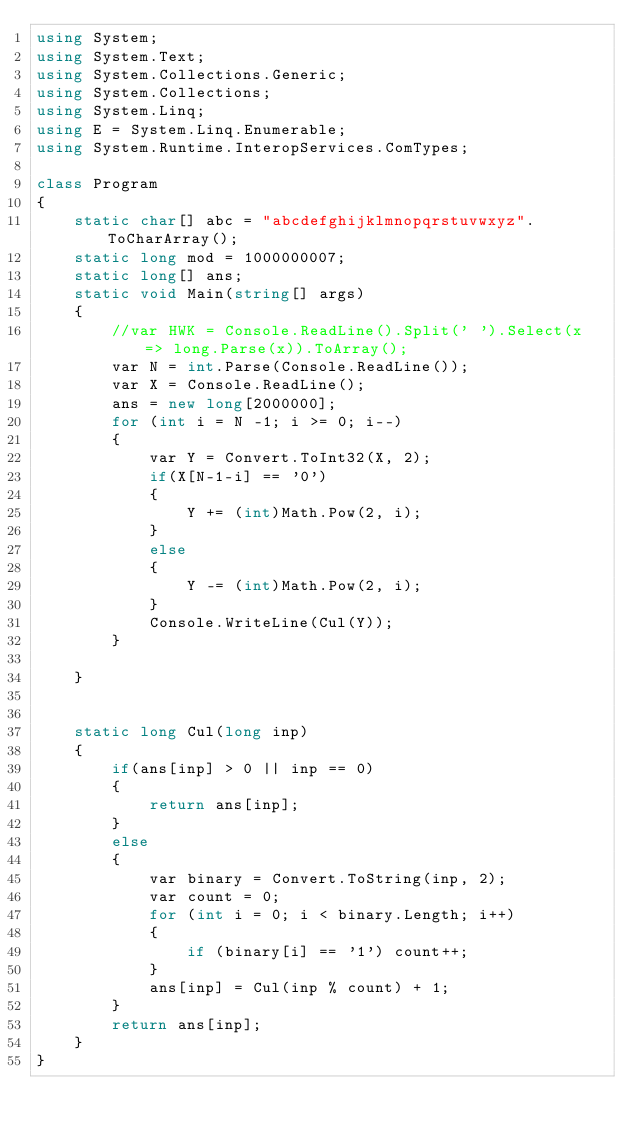Convert code to text. <code><loc_0><loc_0><loc_500><loc_500><_C#_>using System;
using System.Text;
using System.Collections.Generic;
using System.Collections;
using System.Linq;
using E = System.Linq.Enumerable;
using System.Runtime.InteropServices.ComTypes;

class Program
{
    static char[] abc = "abcdefghijklmnopqrstuvwxyz".ToCharArray();
    static long mod = 1000000007;
    static long[] ans;
    static void Main(string[] args)
    {
        //var HWK = Console.ReadLine().Split(' ').Select(x => long.Parse(x)).ToArray();
        var N = int.Parse(Console.ReadLine());
        var X = Console.ReadLine();
        ans = new long[2000000];
        for (int i = N -1; i >= 0; i--)
        {
            var Y = Convert.ToInt32(X, 2);
            if(X[N-1-i] == '0')
            {
                Y += (int)Math.Pow(2, i);
            }
            else
            {
                Y -= (int)Math.Pow(2, i);
            }
            Console.WriteLine(Cul(Y));
        }
        
    }


    static long Cul(long inp)
    {
        if(ans[inp] > 0 || inp == 0)
        {
            return ans[inp];
        }
        else
        {
            var binary = Convert.ToString(inp, 2);
            var count = 0;
            for (int i = 0; i < binary.Length; i++)
            {
                if (binary[i] == '1') count++;
            }
            ans[inp] = Cul(inp % count) + 1;
        }
        return ans[inp];
    }
}
</code> 